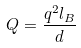Convert formula to latex. <formula><loc_0><loc_0><loc_500><loc_500>Q = \frac { q ^ { 2 } l _ { B } } { d }</formula> 